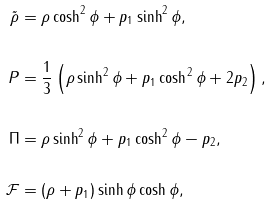<formula> <loc_0><loc_0><loc_500><loc_500>\tilde { \rho } & = \rho \cosh ^ { 2 } \phi + p _ { 1 } \sinh ^ { 2 } \phi , \\ & \\ P & = \frac { 1 } { 3 } \left ( \rho \sinh ^ { 2 } \phi + p _ { 1 } \cosh ^ { 2 } \phi + 2 p _ { 2 } \right ) , \\ & \\ \Pi & = \rho \sinh ^ { 2 } \phi + p _ { 1 } \cosh ^ { 2 } \phi - p _ { 2 } , \\ & \\ \mathcal { F } & = ( \rho + p _ { 1 } ) \sinh \phi \cosh \phi ,</formula> 